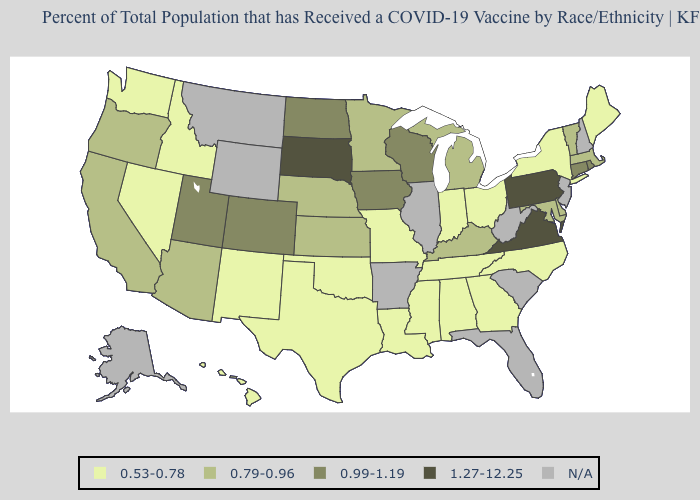Does Utah have the highest value in the USA?
Answer briefly. No. What is the value of Arkansas?
Concise answer only. N/A. What is the value of Colorado?
Short answer required. 0.99-1.19. Name the states that have a value in the range N/A?
Keep it brief. Alaska, Arkansas, Florida, Illinois, Montana, New Hampshire, New Jersey, South Carolina, West Virginia, Wyoming. Name the states that have a value in the range N/A?
Keep it brief. Alaska, Arkansas, Florida, Illinois, Montana, New Hampshire, New Jersey, South Carolina, West Virginia, Wyoming. What is the value of South Dakota?
Be succinct. 1.27-12.25. Which states have the lowest value in the Northeast?
Short answer required. Maine, New York. Does Pennsylvania have the highest value in the Northeast?
Give a very brief answer. Yes. What is the highest value in the USA?
Quick response, please. 1.27-12.25. What is the value of South Dakota?
Give a very brief answer. 1.27-12.25. What is the value of New Hampshire?
Quick response, please. N/A. Does the first symbol in the legend represent the smallest category?
Keep it brief. Yes. Which states have the highest value in the USA?
Quick response, please. Pennsylvania, South Dakota, Virginia. What is the value of Alabama?
Concise answer only. 0.53-0.78. 